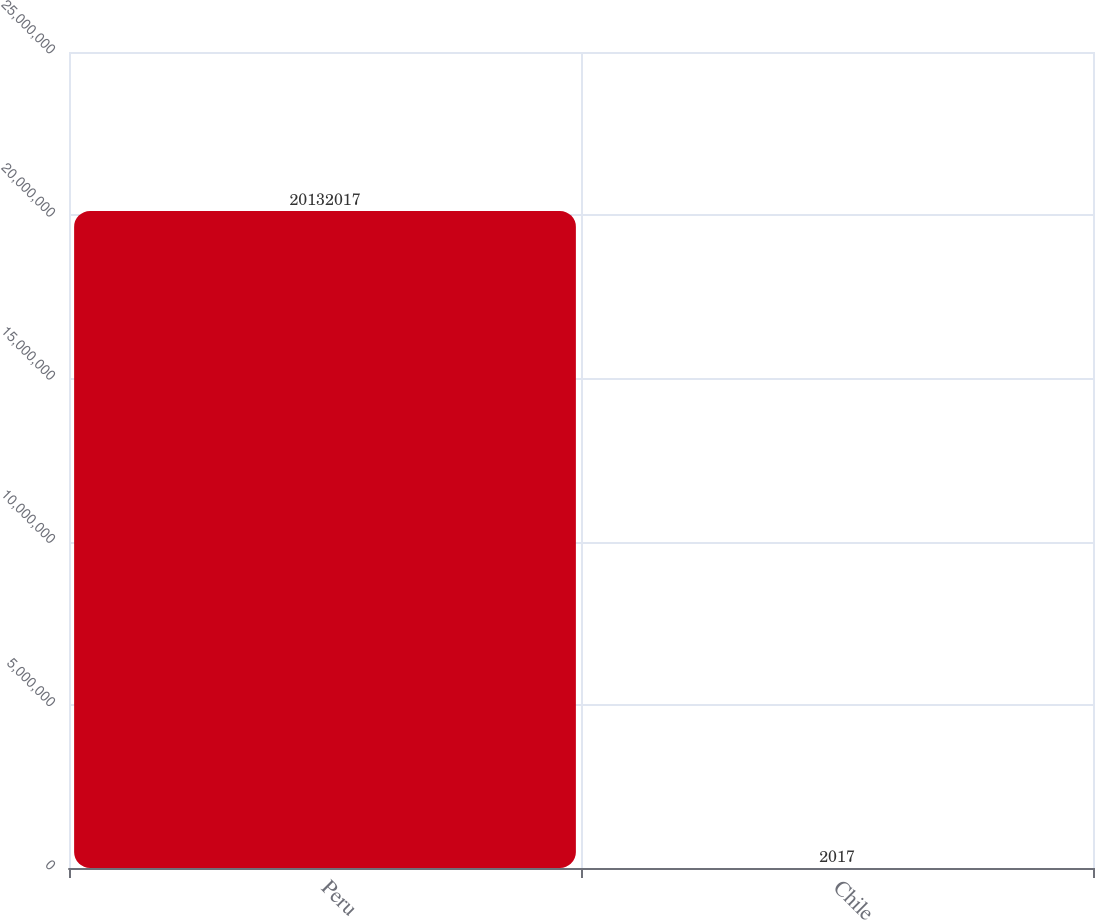Convert chart to OTSL. <chart><loc_0><loc_0><loc_500><loc_500><bar_chart><fcel>Peru<fcel>Chile<nl><fcel>2.0132e+07<fcel>2017<nl></chart> 